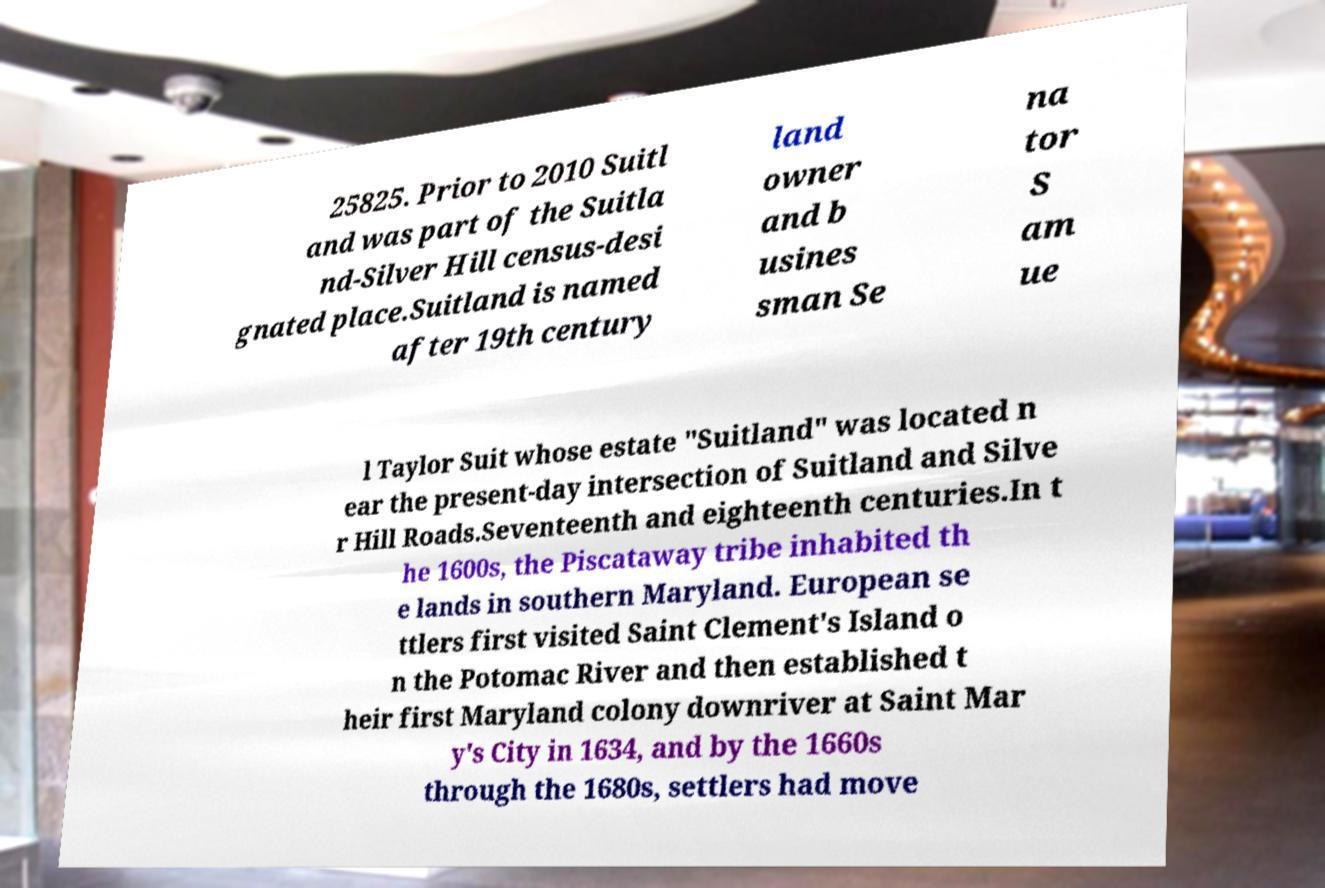I need the written content from this picture converted into text. Can you do that? 25825. Prior to 2010 Suitl and was part of the Suitla nd-Silver Hill census-desi gnated place.Suitland is named after 19th century land owner and b usines sman Se na tor S am ue l Taylor Suit whose estate "Suitland" was located n ear the present-day intersection of Suitland and Silve r Hill Roads.Seventeenth and eighteenth centuries.In t he 1600s, the Piscataway tribe inhabited th e lands in southern Maryland. European se ttlers first visited Saint Clement's Island o n the Potomac River and then established t heir first Maryland colony downriver at Saint Mar y's City in 1634, and by the 1660s through the 1680s, settlers had move 